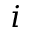<formula> <loc_0><loc_0><loc_500><loc_500>i</formula> 